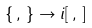<formula> <loc_0><loc_0><loc_500><loc_500>\{ \, , \, \} \rightarrow i [ \, , \, ]</formula> 